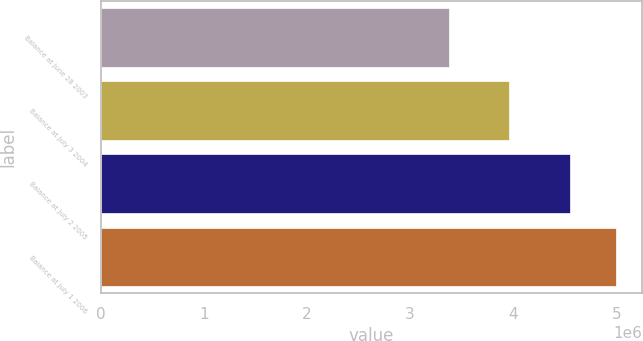<chart> <loc_0><loc_0><loc_500><loc_500><bar_chart><fcel>Balance at June 28 2003<fcel>Balance at July 3 2004<fcel>Balance at July 2 2005<fcel>Balance at July 1 2006<nl><fcel>3.37385e+06<fcel>3.95971e+06<fcel>4.55238e+06<fcel>4.99944e+06<nl></chart> 